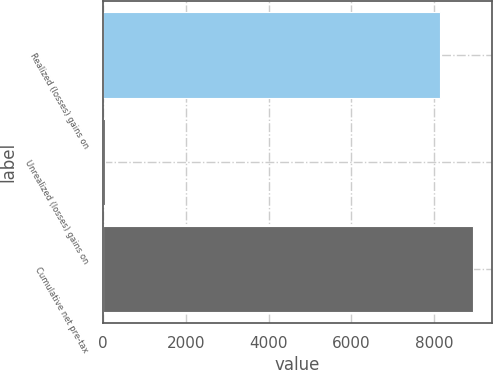Convert chart to OTSL. <chart><loc_0><loc_0><loc_500><loc_500><bar_chart><fcel>Realized (losses) gains on<fcel>Unrealized (losses) gains on<fcel>Cumulative net pre-tax<nl><fcel>8138<fcel>39<fcel>8951.8<nl></chart> 